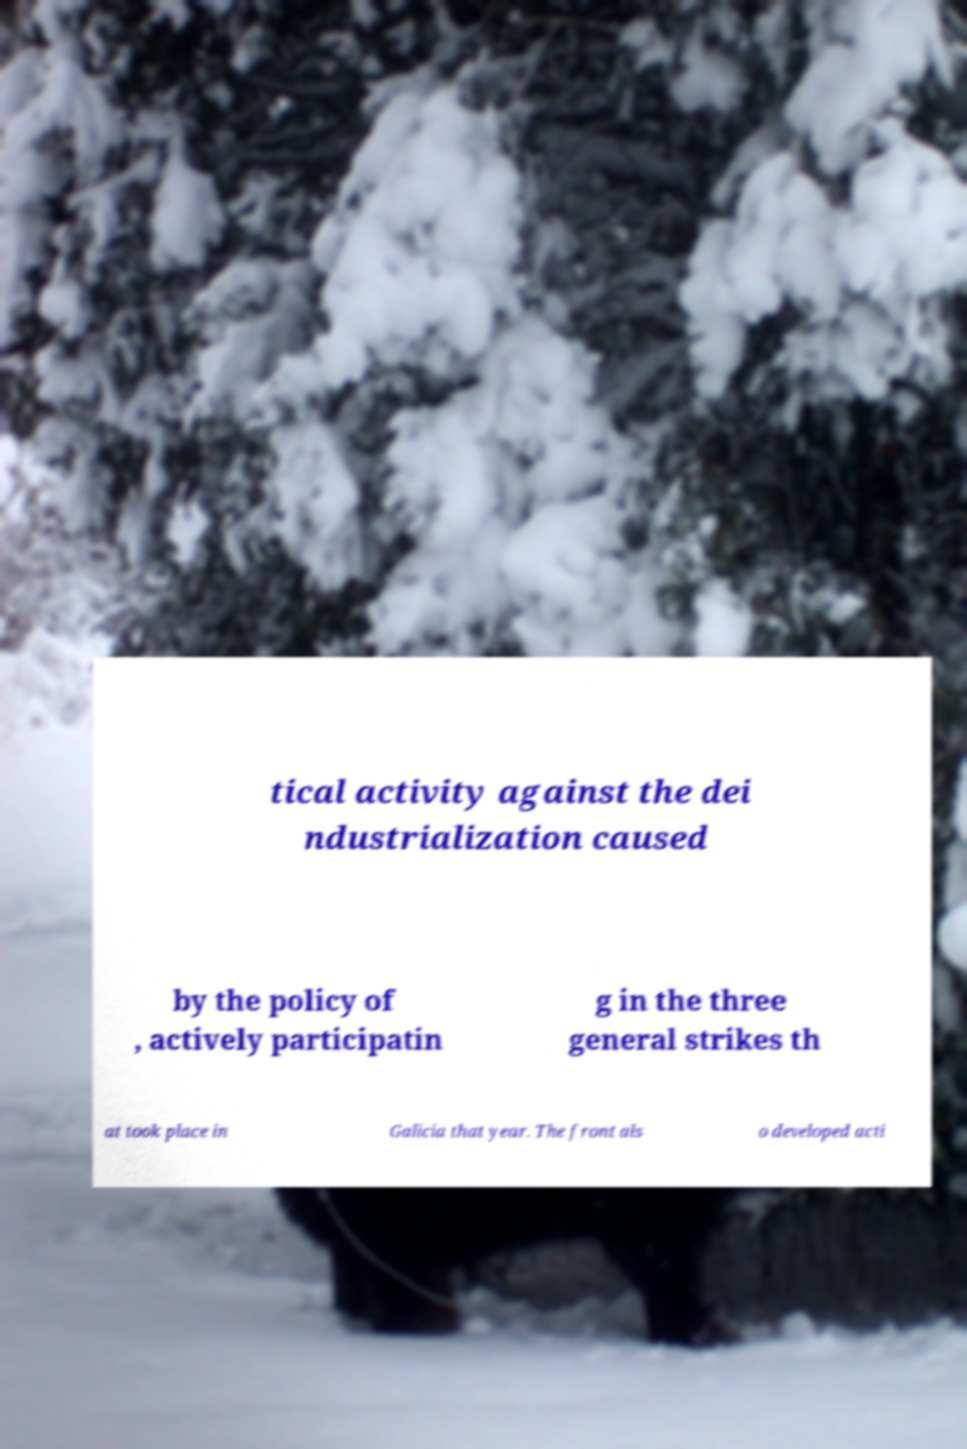There's text embedded in this image that I need extracted. Can you transcribe it verbatim? tical activity against the dei ndustrialization caused by the policy of , actively participatin g in the three general strikes th at took place in Galicia that year. The front als o developed acti 